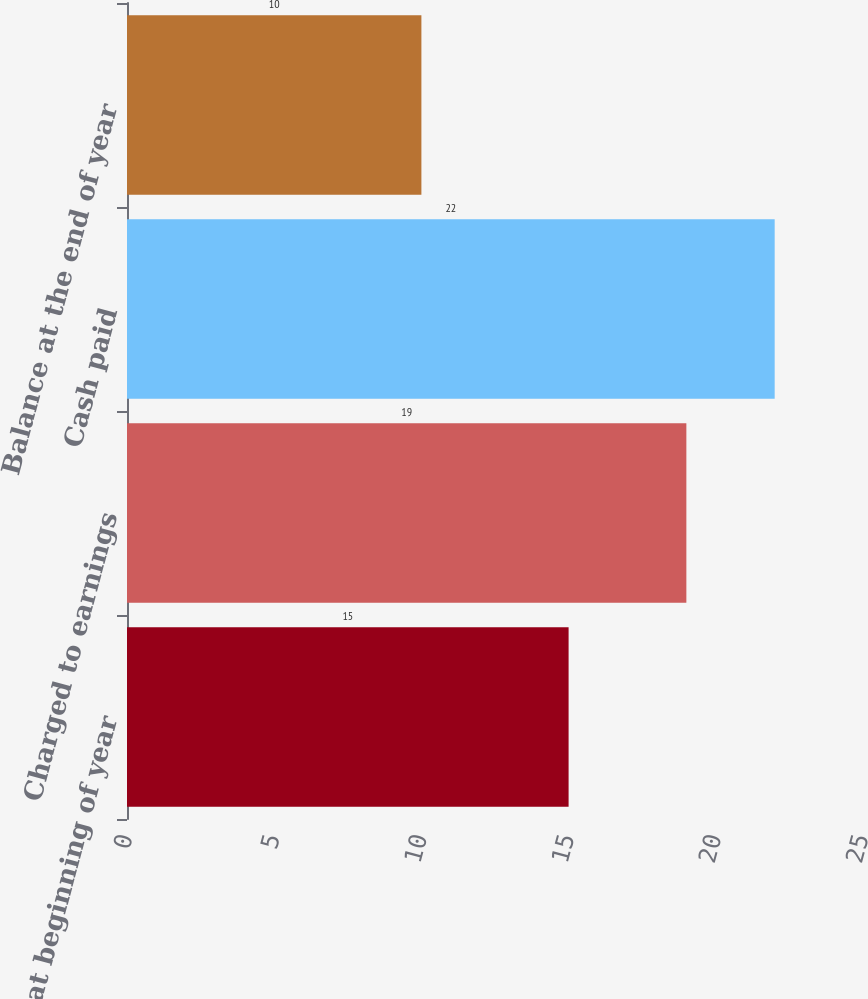Convert chart. <chart><loc_0><loc_0><loc_500><loc_500><bar_chart><fcel>Balance at beginning of year<fcel>Charged to earnings<fcel>Cash paid<fcel>Balance at the end of year<nl><fcel>15<fcel>19<fcel>22<fcel>10<nl></chart> 